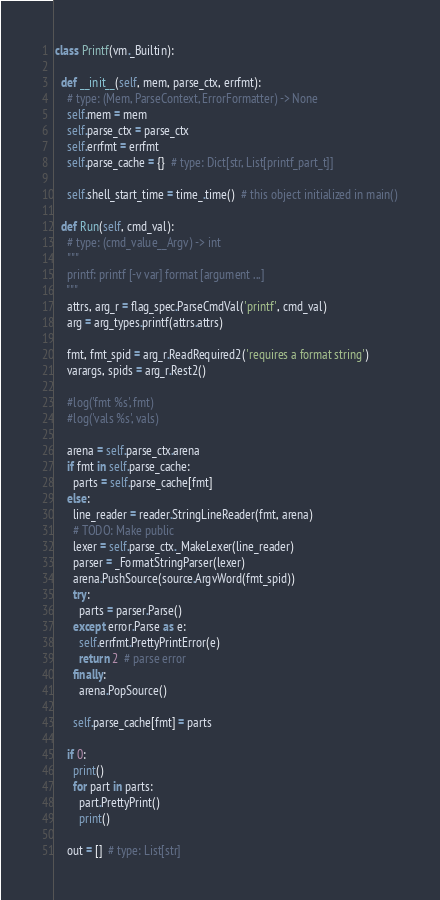Convert code to text. <code><loc_0><loc_0><loc_500><loc_500><_Python_>
class Printf(vm._Builtin):

  def __init__(self, mem, parse_ctx, errfmt):
    # type: (Mem, ParseContext, ErrorFormatter) -> None
    self.mem = mem
    self.parse_ctx = parse_ctx
    self.errfmt = errfmt
    self.parse_cache = {}  # type: Dict[str, List[printf_part_t]]

    self.shell_start_time = time_.time()  # this object initialized in main()

  def Run(self, cmd_val):
    # type: (cmd_value__Argv) -> int
    """
    printf: printf [-v var] format [argument ...]
    """
    attrs, arg_r = flag_spec.ParseCmdVal('printf', cmd_val)
    arg = arg_types.printf(attrs.attrs)

    fmt, fmt_spid = arg_r.ReadRequired2('requires a format string')
    varargs, spids = arg_r.Rest2()

    #log('fmt %s', fmt)
    #log('vals %s', vals)

    arena = self.parse_ctx.arena
    if fmt in self.parse_cache:
      parts = self.parse_cache[fmt]
    else:
      line_reader = reader.StringLineReader(fmt, arena)
      # TODO: Make public
      lexer = self.parse_ctx._MakeLexer(line_reader)
      parser = _FormatStringParser(lexer)
      arena.PushSource(source.ArgvWord(fmt_spid))
      try:
        parts = parser.Parse()
      except error.Parse as e:
        self.errfmt.PrettyPrintError(e)
        return 2  # parse error
      finally:
        arena.PopSource()

      self.parse_cache[fmt] = parts

    if 0:
      print()
      for part in parts:
        part.PrettyPrint()
        print()

    out = []  # type: List[str]</code> 